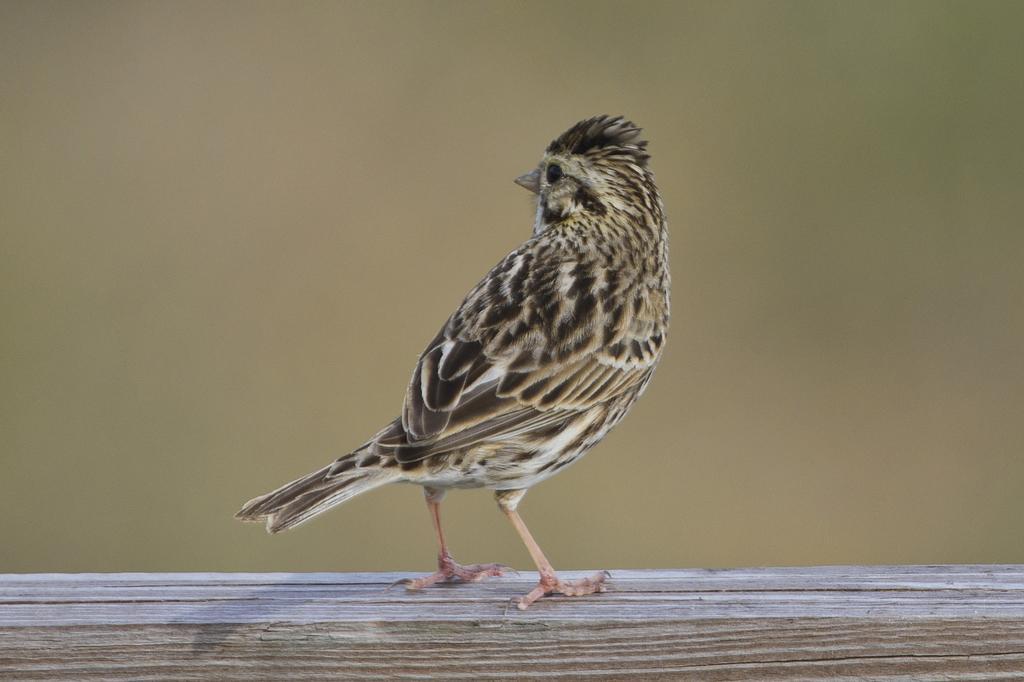Could you give a brief overview of what you see in this image? In this image in the center there is a bird and the background is blurry. 